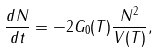Convert formula to latex. <formula><loc_0><loc_0><loc_500><loc_500>\frac { d N } { d t } = - 2 G _ { 0 } ( T ) \frac { N ^ { 2 } } { V ( T ) } ,</formula> 